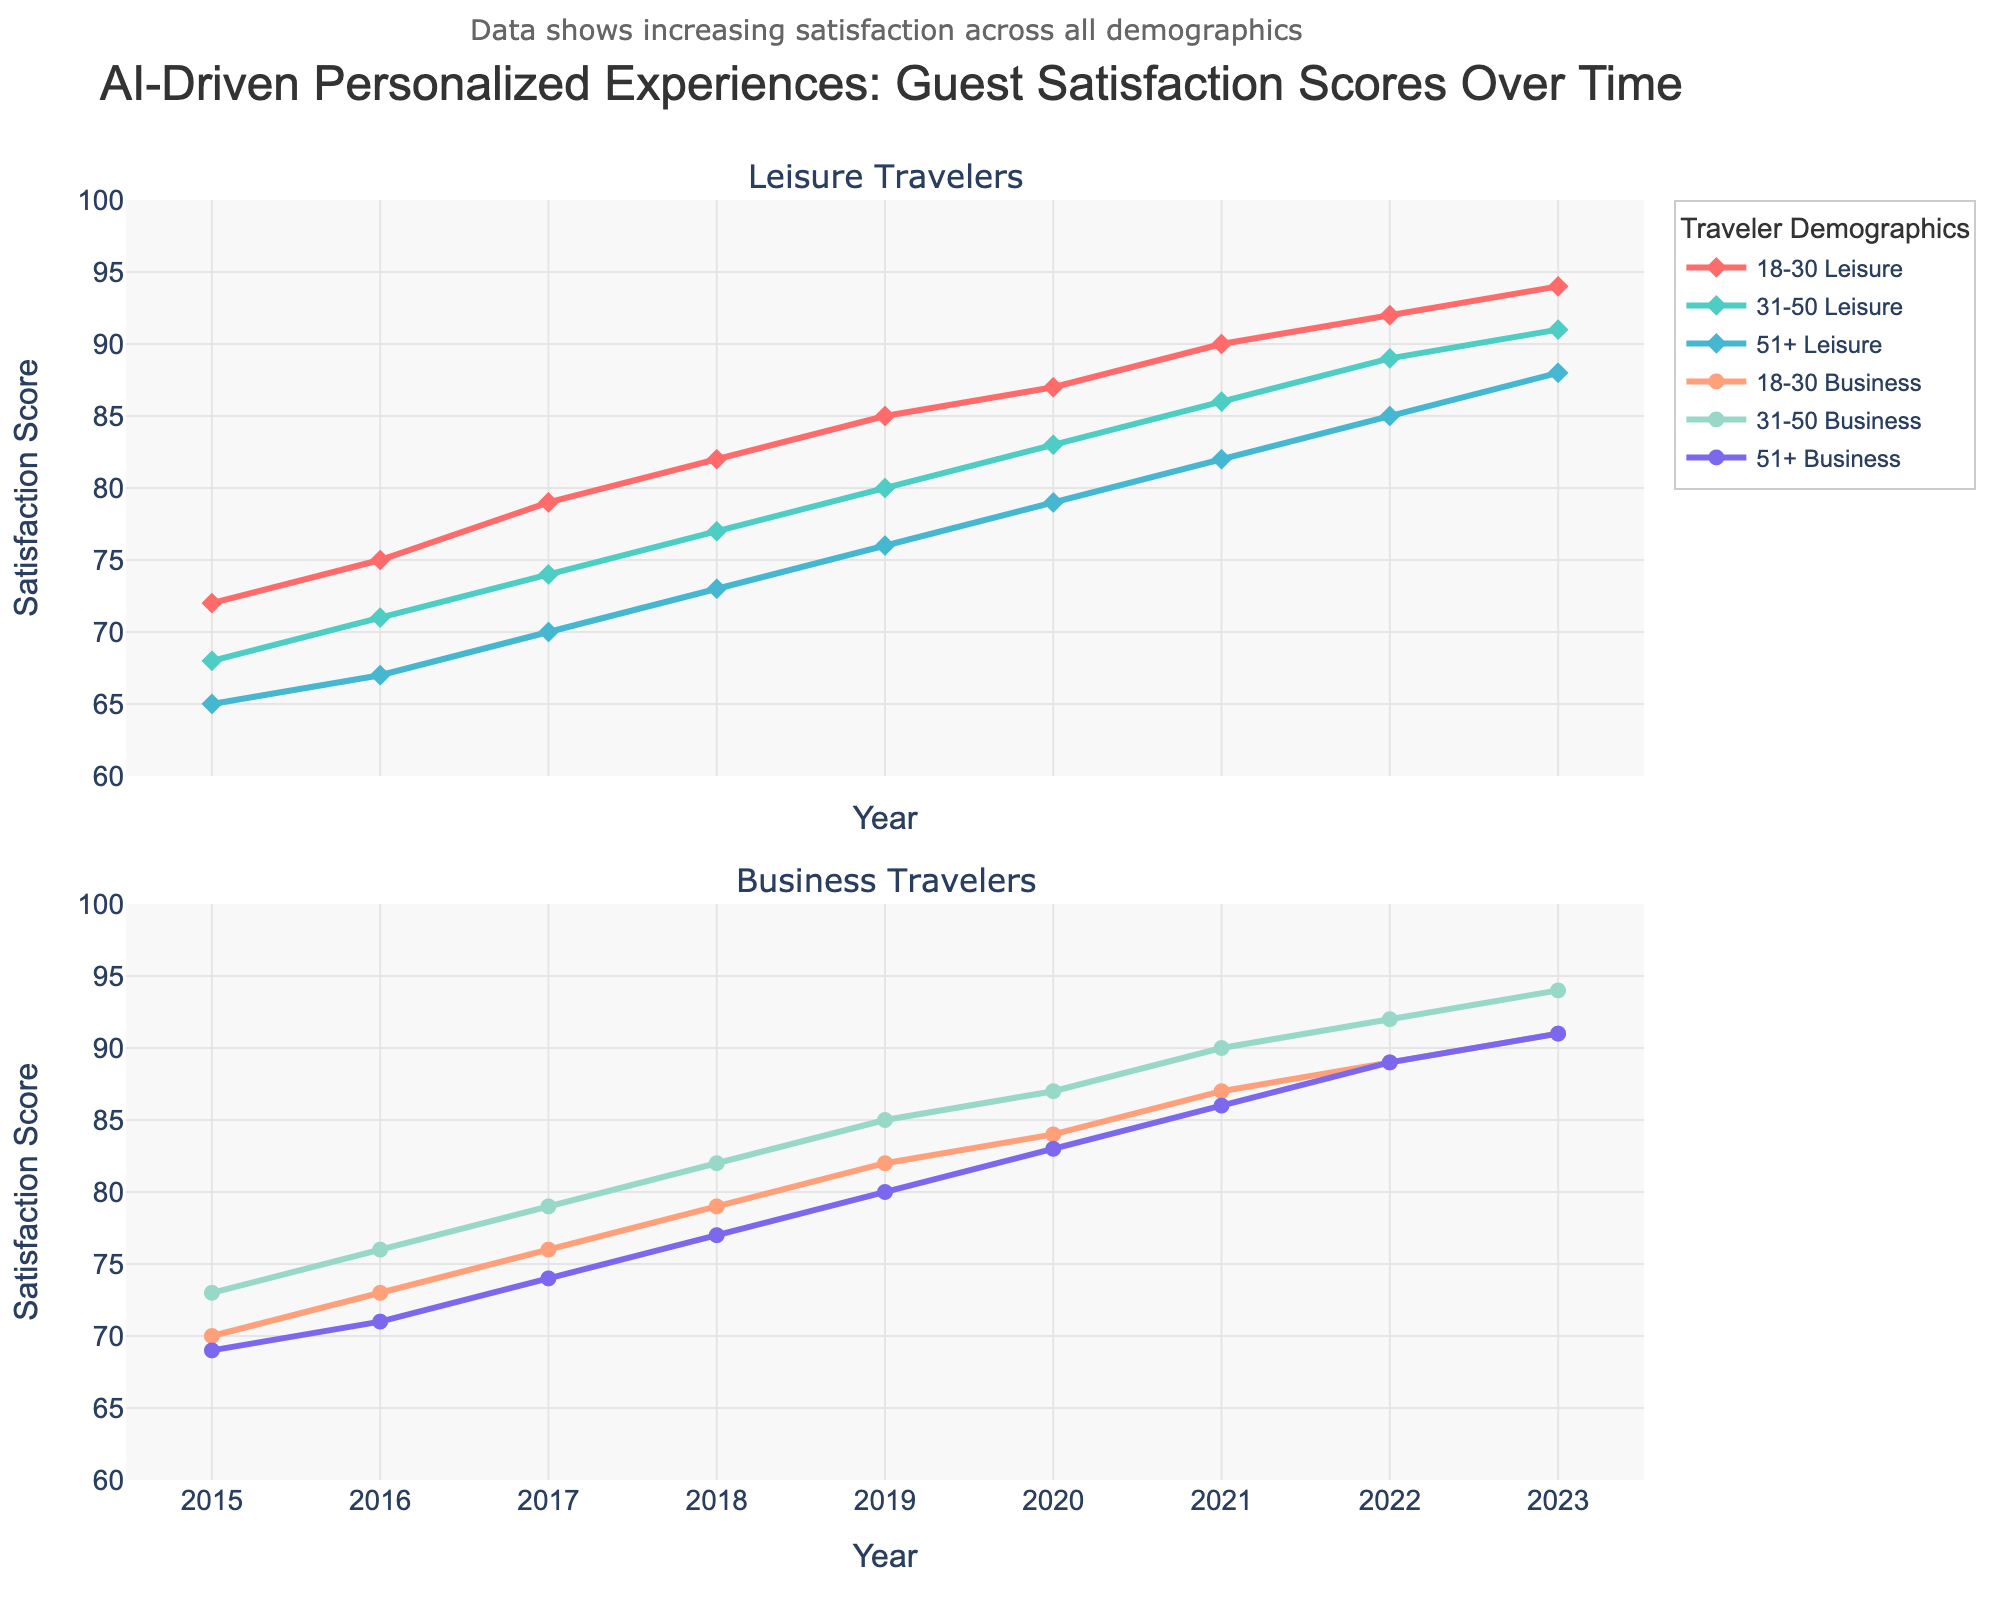How did the satisfaction scores for the 18-30 leisure traveler group change from 2015 to 2023? Observe the 18-30 leisure line in the leisure travelers subplot. In 2015, the score was 72; in 2023, it increased to 94. The change is 94 - 72 = 22.
Answer: Increased by 22 Which traveler demographic had the highest satisfaction score in 2023? Compare all satisfaction scores for 2023. The 31-50 and 18-30 business traveler groups both have a score of 94 in 2023, the highest among all groups.
Answer: 31-50 Business and 18-30 Business By how much did the satisfaction score for the 31-50 business travelers increase from 2015 to 2023? In the business travelers subplot, observe the 31-50 business line. In 2015, the score was 73, and in 2023, it was 94. The increase is 94 - 73 = 21.
Answer: Increased by 21 Which two groups showed identical satisfaction scores throughout the entire timeframe? Look for lines in both subplots that overlap or are identical. The 18-30 and 31-50 business groups have the same scores for each year.
Answer: 18-30 Business and 31-50 Business What is the average satisfaction score of the 51+ leisure traveler group over the entire period? Sum the scores of the 51+ leisure group across all years: 65+67+70+73+76+79+82+85+88 = 685. There are 9 years, so the average is 685 / 9 = approximately 76.11.
Answer: Approximately 76.11 Between 2019 and 2020, which group's satisfaction score saw the highest increase, and by how much? Compare the increases for each group from 2019 to 2020. The 31-50 leisure, 51+ leisure, 51+ business, and 31-50 business groups all saw increases of 3 points. None saw a higher increase.
Answer: 31-50 Leisure, 51+ Leisure, 31-50 Business, 51+ Business; increased by 3 points each What is the difference in satisfaction scores between the 18-30 leisure and the 51+ leisure group in 2023? In 2023, the 18-30 leisure score is 94 and the 51+ leisure score is 88. The difference is 94 - 88 = 6.
Answer: Difference of 6 What was the trend for the 51+ business traveler group from 2015 to 2023? Observe the trend line for the 51+ business group in the business travelers subplot. The scores increase each year, indicating a steady upward trend: from 69 in 2015 to 91 in 2023.
Answer: Steady upward Compare the satisfaction score trends of leisure travelers and business travelers in the 2020-2023 period. Between 2020 and 2023, satisfaction scores for both leisure and business travelers increased consistently. The leisure scores went from 83, 86, 89, 91 for 18-30; 80, 83, 86, 89 for 31-50; and 79, 82, 85, 88 for 51+. Similarly, the business scores went from 84, 87, 89, 91 for 18-30; 84, 87, 89, 91 for 31-50; and 83, 86, 89, 91 for 51+. Both show a general upward trend.
Answer: General upward trend Which demographic had the most consistent increase in guest satisfaction over the years 2015-2023? To find the most consistent increase, observe which line shows the least deviation year-on-year while steadily increasing. The 18-30 business and 31-50 business demographics both exhibit consistent yearly increases from 70 and 73 in 2015 to 91 and 94 in 2023, respectively.
Answer: 18-30 Business and 31-50 Business 